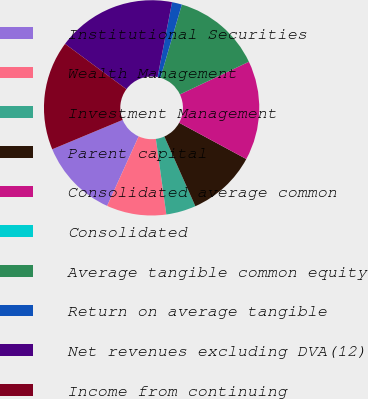Convert chart. <chart><loc_0><loc_0><loc_500><loc_500><pie_chart><fcel>Institutional Securities<fcel>Wealth Management<fcel>Investment Management<fcel>Parent capital<fcel>Consolidated average common<fcel>Consolidated<fcel>Average tangible common equity<fcel>Return on average tangible<fcel>Net revenues excluding DVA(12)<fcel>Income from continuing<nl><fcel>11.94%<fcel>8.96%<fcel>4.48%<fcel>10.45%<fcel>14.93%<fcel>0.0%<fcel>13.43%<fcel>1.49%<fcel>17.91%<fcel>16.42%<nl></chart> 